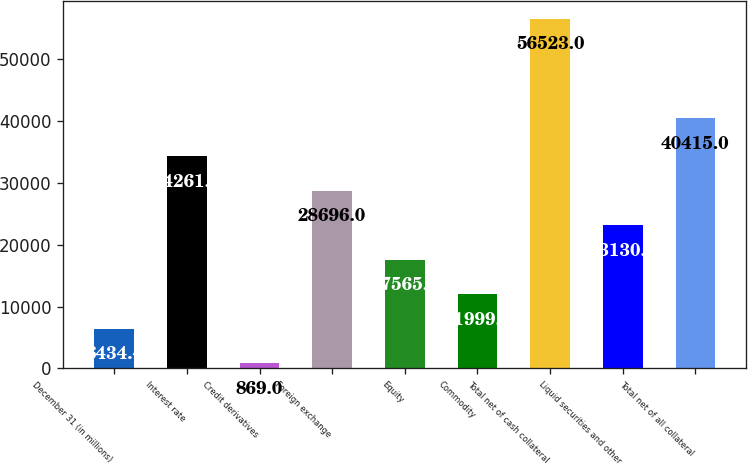Convert chart. <chart><loc_0><loc_0><loc_500><loc_500><bar_chart><fcel>December 31 (in millions)<fcel>Interest rate<fcel>Credit derivatives<fcel>Foreign exchange<fcel>Equity<fcel>Commodity<fcel>Total net of cash collateral<fcel>Liquid securities and other<fcel>Total net of all collateral<nl><fcel>6434.4<fcel>34261.4<fcel>869<fcel>28696<fcel>17565.2<fcel>11999.8<fcel>56523<fcel>23130.6<fcel>40415<nl></chart> 